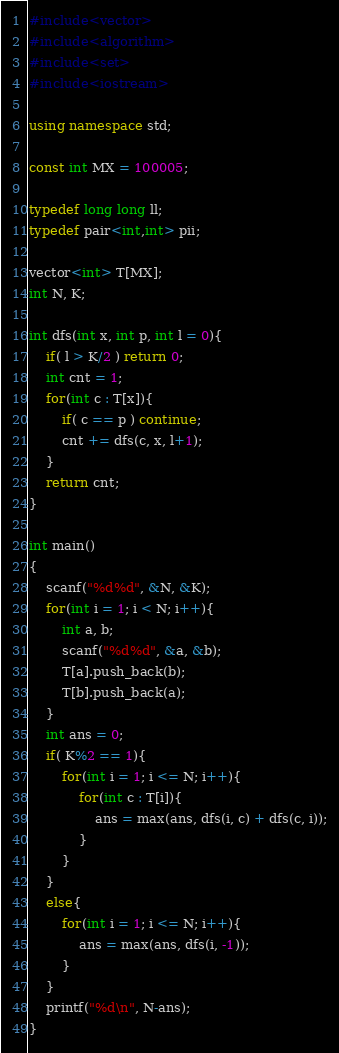Convert code to text. <code><loc_0><loc_0><loc_500><loc_500><_C++_>#include<vector>
#include<algorithm>
#include<set>
#include<iostream>

using namespace std;

const int MX = 100005;

typedef long long ll;
typedef pair<int,int> pii;

vector<int> T[MX];
int N, K;

int dfs(int x, int p, int l = 0){
	if( l > K/2 ) return 0;
	int cnt = 1;
	for(int c : T[x]){
		if( c == p ) continue;
		cnt += dfs(c, x, l+1);
	}
	return cnt;
}

int main()
{
	scanf("%d%d", &N, &K);
	for(int i = 1; i < N; i++){
		int a, b;
		scanf("%d%d", &a, &b);
		T[a].push_back(b);
		T[b].push_back(a);
	}
	int ans = 0;
	if( K%2 == 1){
		for(int i = 1; i <= N; i++){
			for(int c : T[i]){
				ans = max(ans, dfs(i, c) + dfs(c, i));
			}
		}
	}
	else{
		for(int i = 1; i <= N; i++){
			ans = max(ans, dfs(i, -1));
		}
	}
	printf("%d\n", N-ans);
}
</code> 